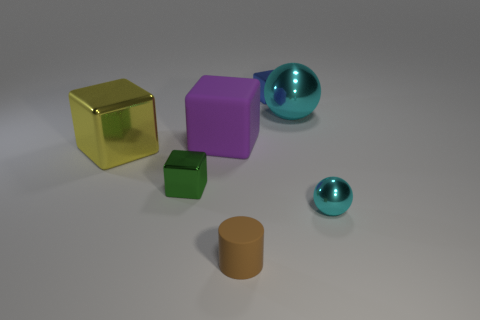Subtract all blue blocks. How many blocks are left? 3 Subtract all purple blocks. How many blocks are left? 3 Add 2 cubes. How many objects exist? 9 Subtract all brown blocks. Subtract all green balls. How many blocks are left? 4 Subtract 0 blue balls. How many objects are left? 7 Subtract all blocks. How many objects are left? 3 Subtract all green blocks. Subtract all large objects. How many objects are left? 3 Add 4 tiny cylinders. How many tiny cylinders are left? 5 Add 5 small cyan spheres. How many small cyan spheres exist? 6 